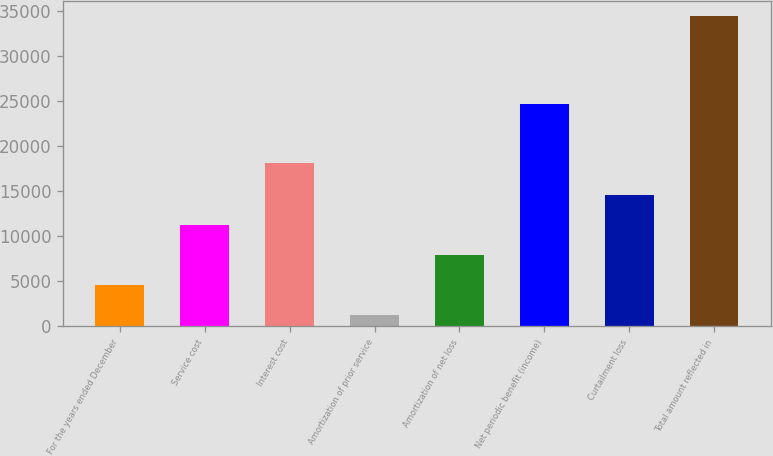Convert chart. <chart><loc_0><loc_0><loc_500><loc_500><bar_chart><fcel>For the years ended December<fcel>Service cost<fcel>Interest cost<fcel>Amortization of prior service<fcel>Amortization of net loss<fcel>Net periodic benefit (income)<fcel>Curtailment loss<fcel>Total amount reflected in<nl><fcel>4591.9<fcel>11217.7<fcel>18115<fcel>1279<fcel>7904.8<fcel>24624<fcel>14530.6<fcel>34408<nl></chart> 